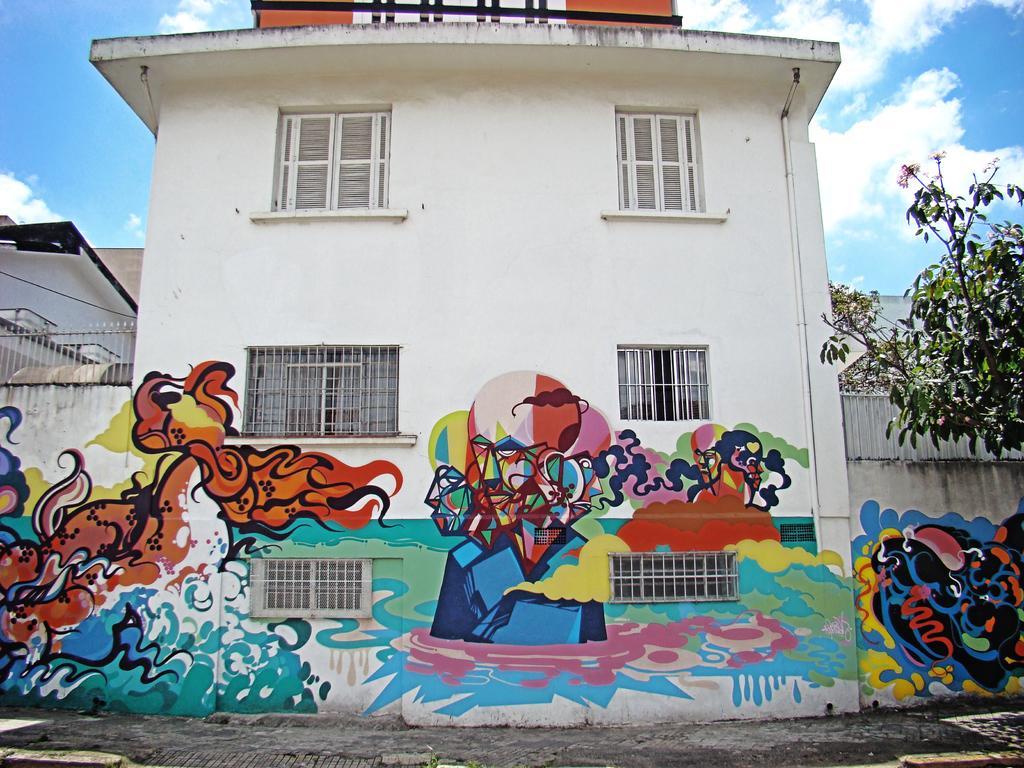In one or two sentences, can you explain what this image depicts? In this image we can see few buildings. On the buildings we can see paintings and windows. At the top we can see the sky. On the right side, we can see a tree. 